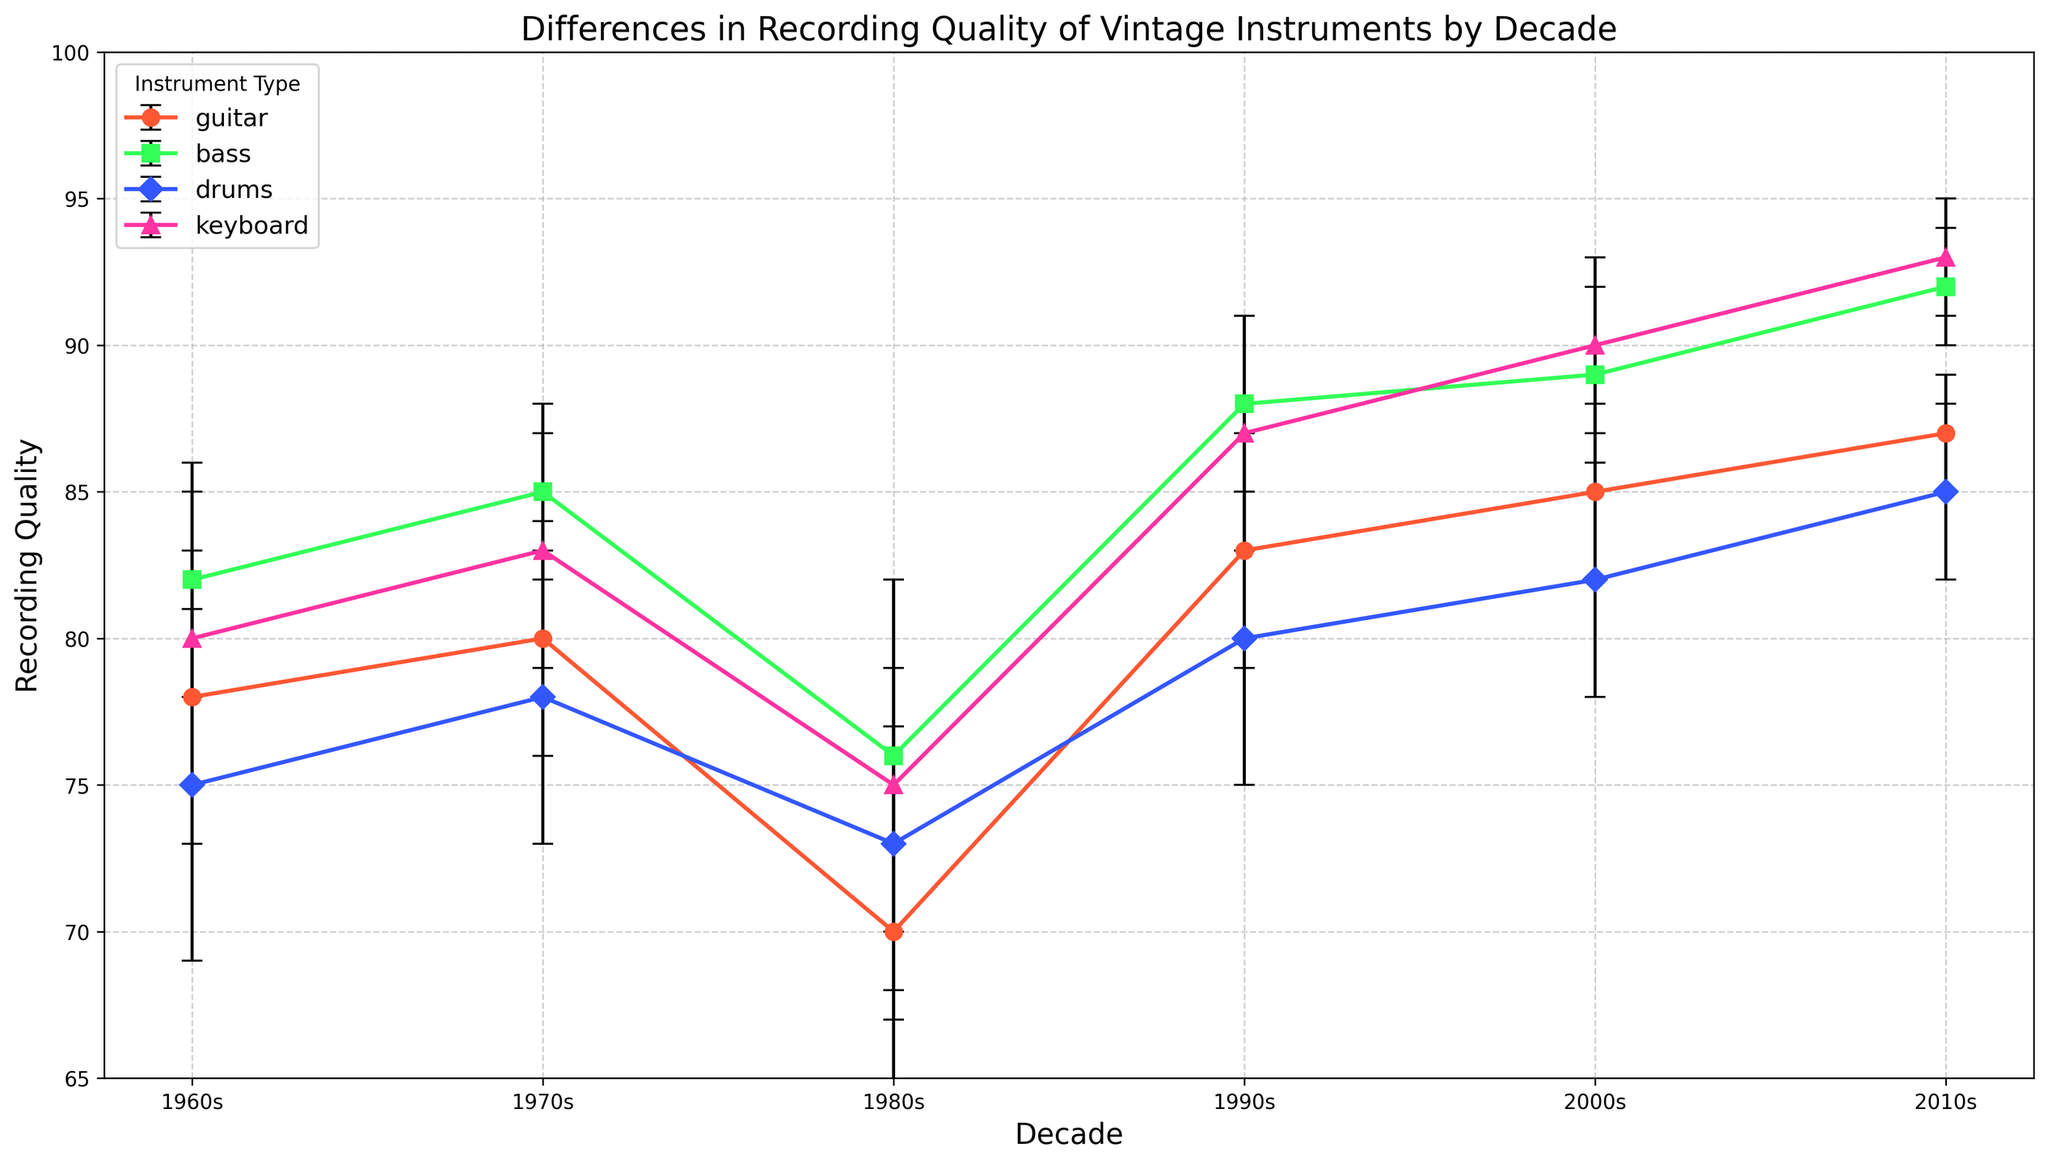Which decade had the highest average recording quality for the keyboard? From the figure, observe that the 2010s decade shows the highest point for the keyboard with a mean quality of 93.
Answer: 2010s What's the difference in mean recording quality between the guitar and bass in the 1980s? Find the mean recording qualities of guitar and bass in the 1980s (70 and 76, respectively), then subtract the former from the latter (76 - 70).
Answer: 6 Compare the error ranges of drums in the 1960s and 2010s. Which one is larger? The error range for drums in the 1960s is 6, and it is 3 in the 2010s. The 1960s has a larger error range.
Answer: 1960s Which instrument type shows the largest improvement in mean recording quality from the 1980s to the 2010s? Calculate the improvement for each instrument type by subtracting the mean quality in the 1980s from that in the 2010s. Guitar (87 - 70 = 17), Bass (92 - 76 = 16), Drums (85 - 73 = 12), Keyboard (93 - 75 = 18). Keyboard shows the largest improvement.
Answer: Keyboard Which decade has the lowest mean recording quality for drums? From the figure, the lowest point for drums appears in the 1980s with a mean quality of 73.
Answer: 1980s By how much does the mean recording quality of the guitar increase from the 1960s to the 1990s? Note the mean recording qualities of the guitar in both decades (1960s and 1990s). The values are 78 and 83, respectively. The increase is 83 - 78 = 5.
Answer: 5 Is the mean recording quality for the bass in the 2000s greater than that for the keyboard in the 1960s? Look at the figures for the bass in the 2000s (89) and keyboard in the 1960s (80). Since 89 > 80, the answer is yes.
Answer: Yes What is the combined error range for the guitar and keyboard in the 1970s? Add the error ranges of the guitar and keyboard in the 1970s. For the guitar, it is 4, and for the keyboard, it is 4. The combined error range is 4 + 4 = 8.
Answer: 8 Which instrument type has the smallest error range in the 2010s? By comparing the error ranges of all instrument types in the 2010s, observe that both guitar and bass have the smallest error range of 2.
Answer: Guitar and Bass 